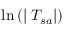Convert formula to latex. <formula><loc_0><loc_0><loc_500><loc_500>\ln \left ( | \nabla T _ { s a } | \right )</formula> 